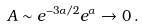<formula> <loc_0><loc_0><loc_500><loc_500>A \sim e ^ { - 3 \alpha / 2 } e ^ { \alpha } \to 0 \, .</formula> 